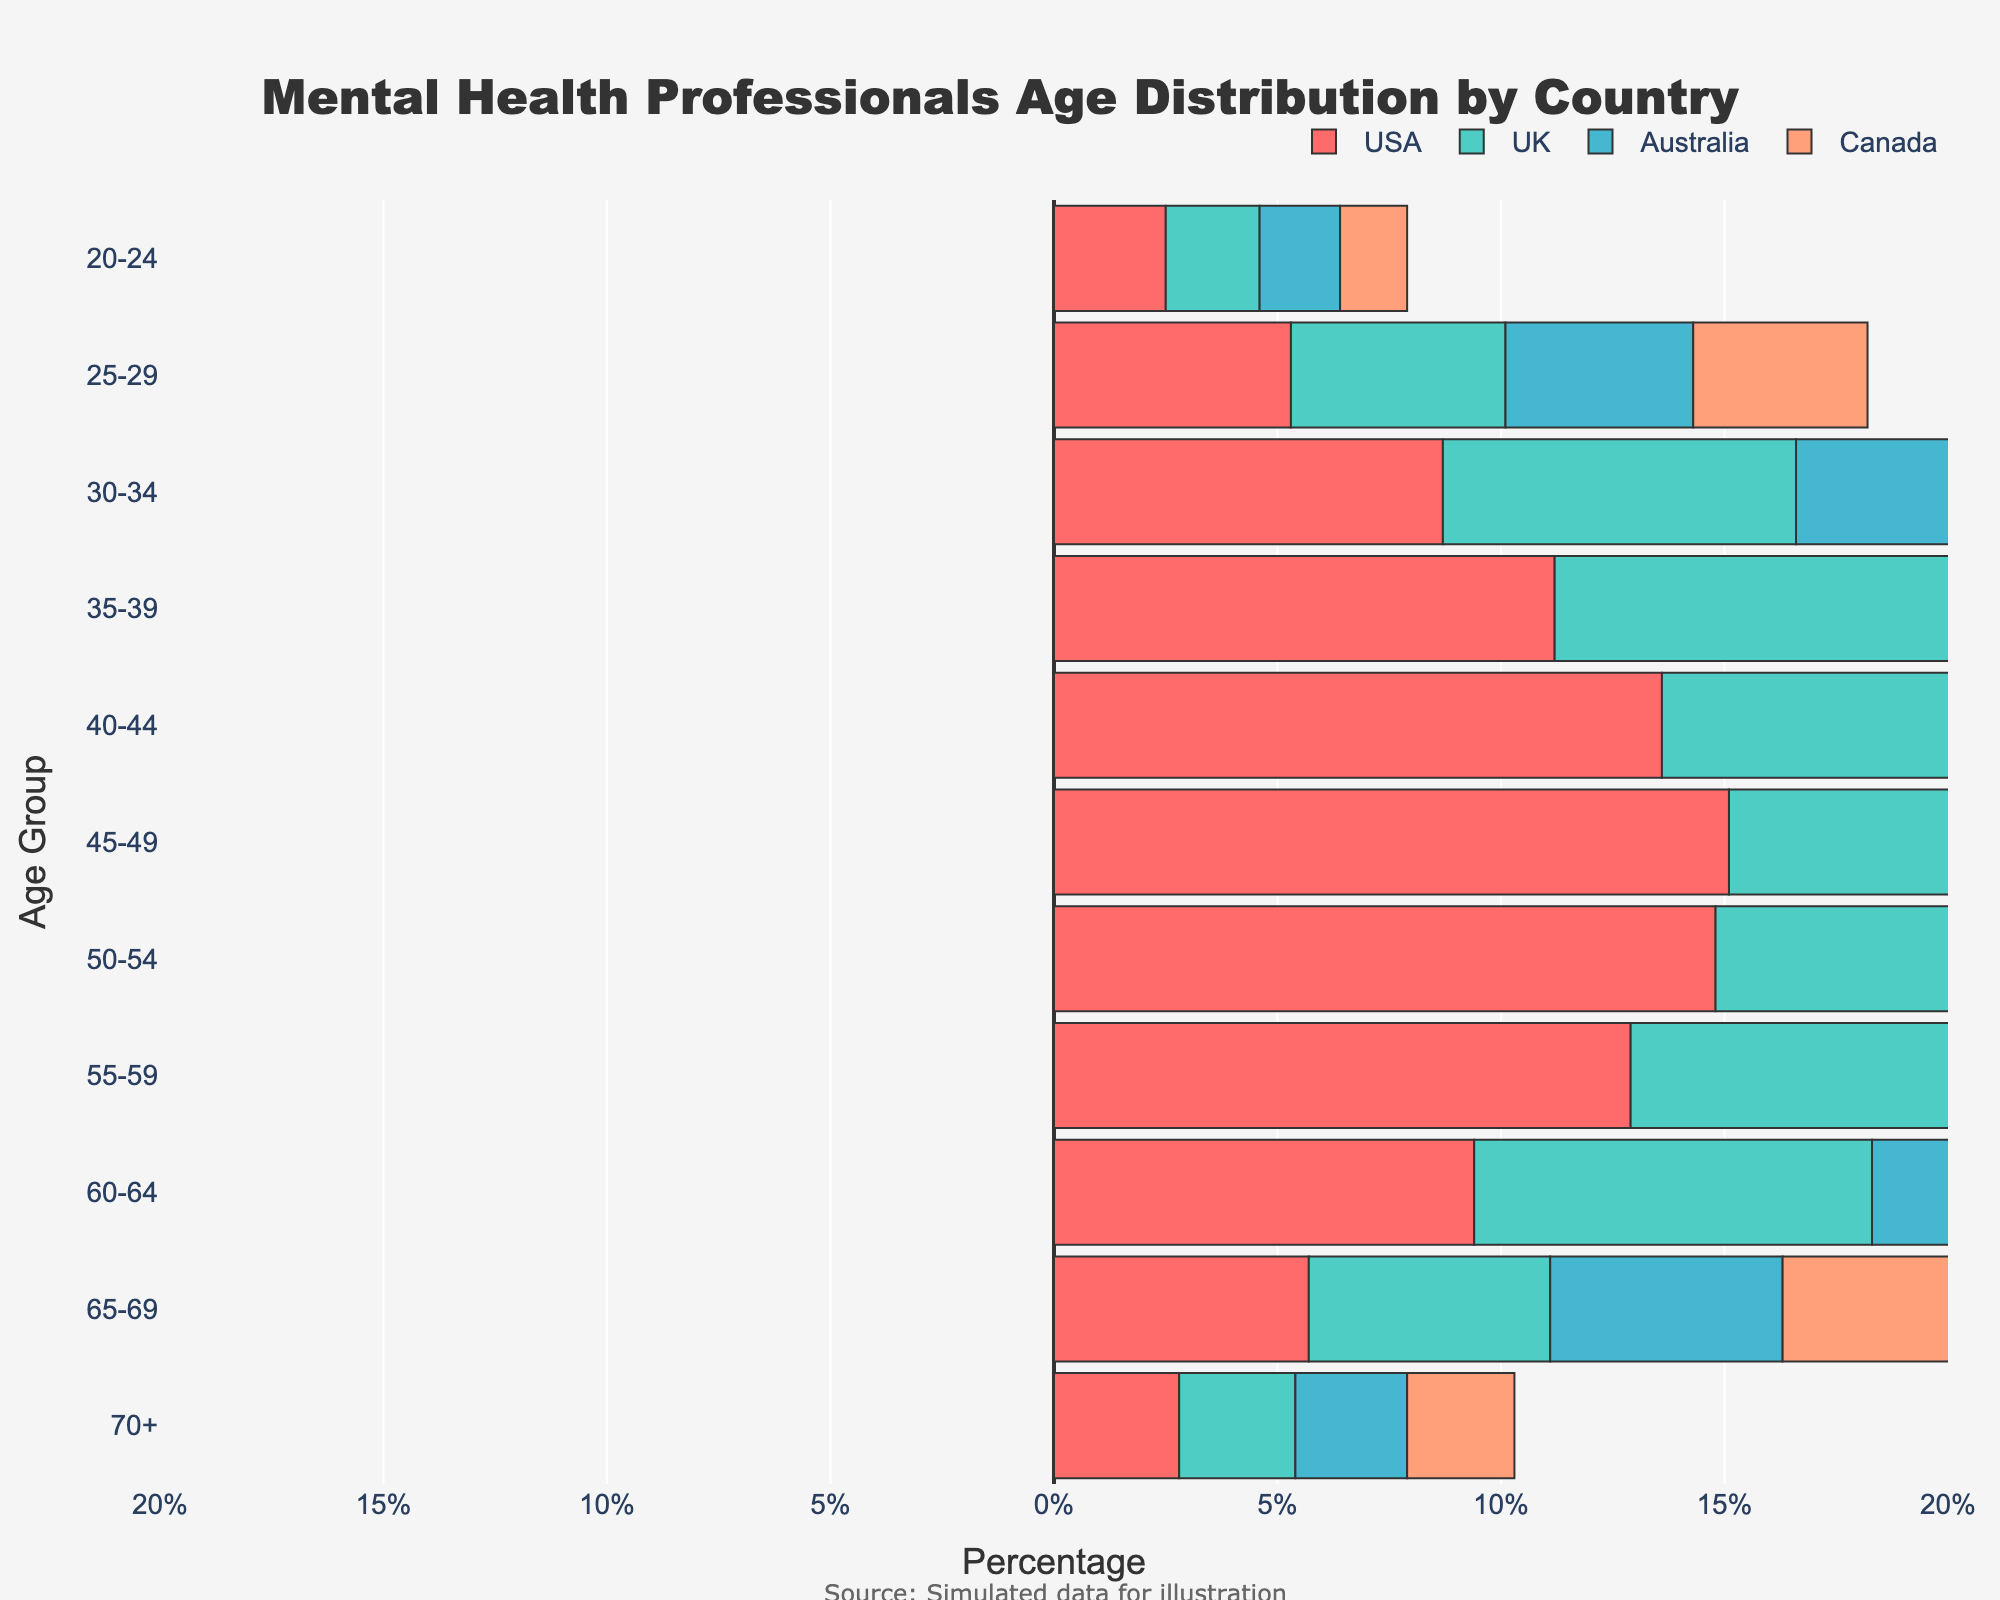What is the title of the figure? The title can be found at the top of the figure. It provides a clear description of the content being visualized.
Answer: Mental Health Professionals Age Distribution by Country Which age group has the highest percentage of mental health professionals in the UK? Look at the bars extending to the right for the UK and identify the age group with the longest bar.
Answer: 45-49 Between which age groups do the USA and Canada show a declining trend in percentages of mental health professionals? Observe the bars on the left for the USA and the bars on the right for Canada, and check how the lengths of the bars change from one age group to the next.
Answer: 45-49 to 70+ How does the percentage of mental health professionals aged 30-34 in Australia compare with those in Canada? Compare the length of the 30-34 bars for Australia (left side, negative) and Canada (right side, positive).
Answer: Higher in Canada Which country has the most uniform age distribution among mental health professionals? Look at the evenness of the bar lengths across different age groups to determine which country's distribution is the most consistent.
Answer: UK By how much does the percentage of mental health professionals aged 40-44 in the USA exceed that of those aged 20-24 in the USA? Subtract the percentage value of the 20-24 age group from that of the 40-44 age group for the USA.
Answer: 11.1% What is the total percentage of mental health professionals aged 60+ in Canada? Sum the percentages of the 60-64, 65-69, and 70+ age groups for Canada.
Answer: 15.4% Which country has the smallest percentage of mental health professionals in the 55-59 age group? Compare the lengths of the bars corresponding to the 55-59 age group across all countries.
Answer: Australia Is there any age group where all countries have approximately the same percentage of mental health professionals? Check for age groups where the lengths of the bars for all countries are similar in size.
Answer: 70+ Between the age groups 35-39 and 40-44, which one shows a greater difference in percentage between the USA and UK? Calculate the difference in percentages for both age groups between the USA and UK, and compare these differences.
Answer: 40-44 